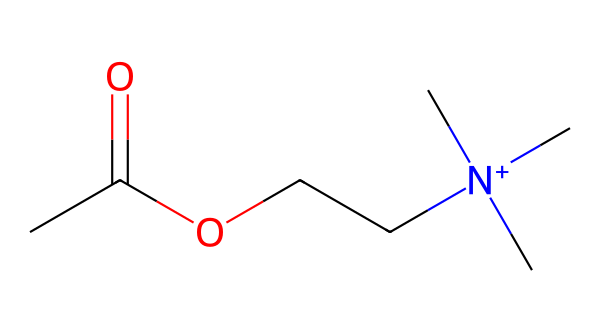What is the functional group present in this molecule? The presence of the -O- and a carbonyl (C=O) indicates that this molecule has an ester functional group.
Answer: ester How many carbon atoms are in the structure? Counting the carbon atoms: there are three in the side chain (including the one in the ester) and one in the carbonyl, totaling four carbon atoms.
Answer: four What is the central atom of this molecule that contributes to its positive charge? The central nitrogen atom is bonded to four groups, resulting in a positive charge due to the overall electron count.
Answer: nitrogen Which part of this chemical structure is responsible for forming acetylcholine? The ester bond (-O-) between the acetyl group (CC(=O)O) and the nitrogen-containing group contributes to the formation of acetylcholine.
Answer: ester bond How many oxygen atoms are present in this molecule? Examining the structure, there are two oxygen atoms: one in the ester formation and one in the carbonyl functional group.
Answer: two What type of bond connects the acetyl group to the nitrogen atom in this molecule? The connection between the acetyl group and the nitrogen atom is through an ester bond, specifically an ether bond with a positively charged nitrogen.
Answer: ester bond 